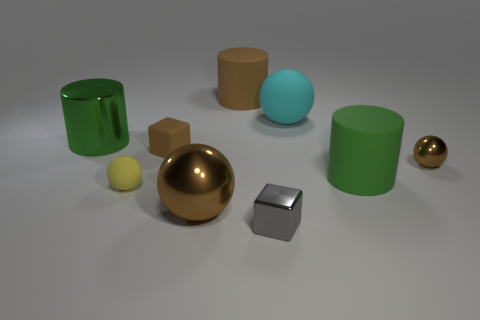Subtract all yellow balls. How many balls are left? 3 Subtract all purple cubes. How many brown balls are left? 2 Subtract all large cyan rubber balls. How many balls are left? 3 Add 1 brown matte cylinders. How many objects exist? 10 Subtract all red spheres. Subtract all red cylinders. How many spheres are left? 4 Subtract all cylinders. How many objects are left? 6 Add 6 gray metallic things. How many gray metallic things are left? 7 Add 7 brown spheres. How many brown spheres exist? 9 Subtract 1 yellow balls. How many objects are left? 8 Subtract all small balls. Subtract all small brown shiny spheres. How many objects are left? 6 